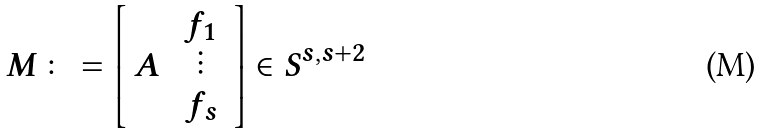Convert formula to latex. <formula><loc_0><loc_0><loc_500><loc_500>M \colon = \left [ \begin{array} { c c } A & \begin{array} { c } f _ { 1 } \\ \vdots \\ f _ { s } \end{array} \\ \end{array} \right ] \in S ^ { s , s + 2 }</formula> 